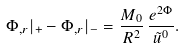<formula> <loc_0><loc_0><loc_500><loc_500>\Phi _ { , r } | _ { + } - \Phi _ { , r } | _ { - } = \frac { M _ { 0 } } { R ^ { 2 } } \, \frac { e ^ { 2 \Phi } } { \tilde { u } ^ { 0 } } .</formula> 